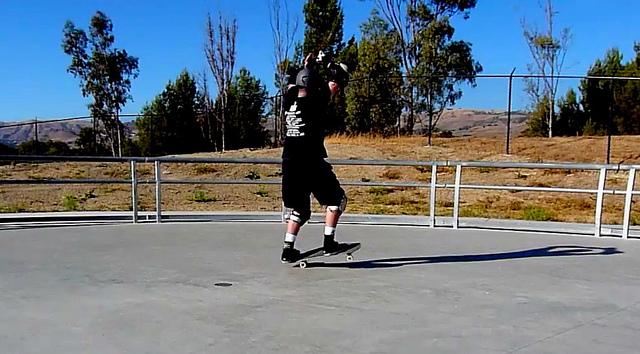Is the grass green?
Answer briefly. No. What sport are they playing?
Short answer required. Skateboarding. Is the skater just beginning?
Quick response, please. Yes. What is the man riding?
Concise answer only. Skateboard. Are there clouds in the sky?
Write a very short answer. No. 